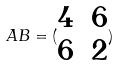<formula> <loc_0><loc_0><loc_500><loc_500>A B = ( \begin{matrix} 4 & 6 \\ 6 & 2 \end{matrix} )</formula> 